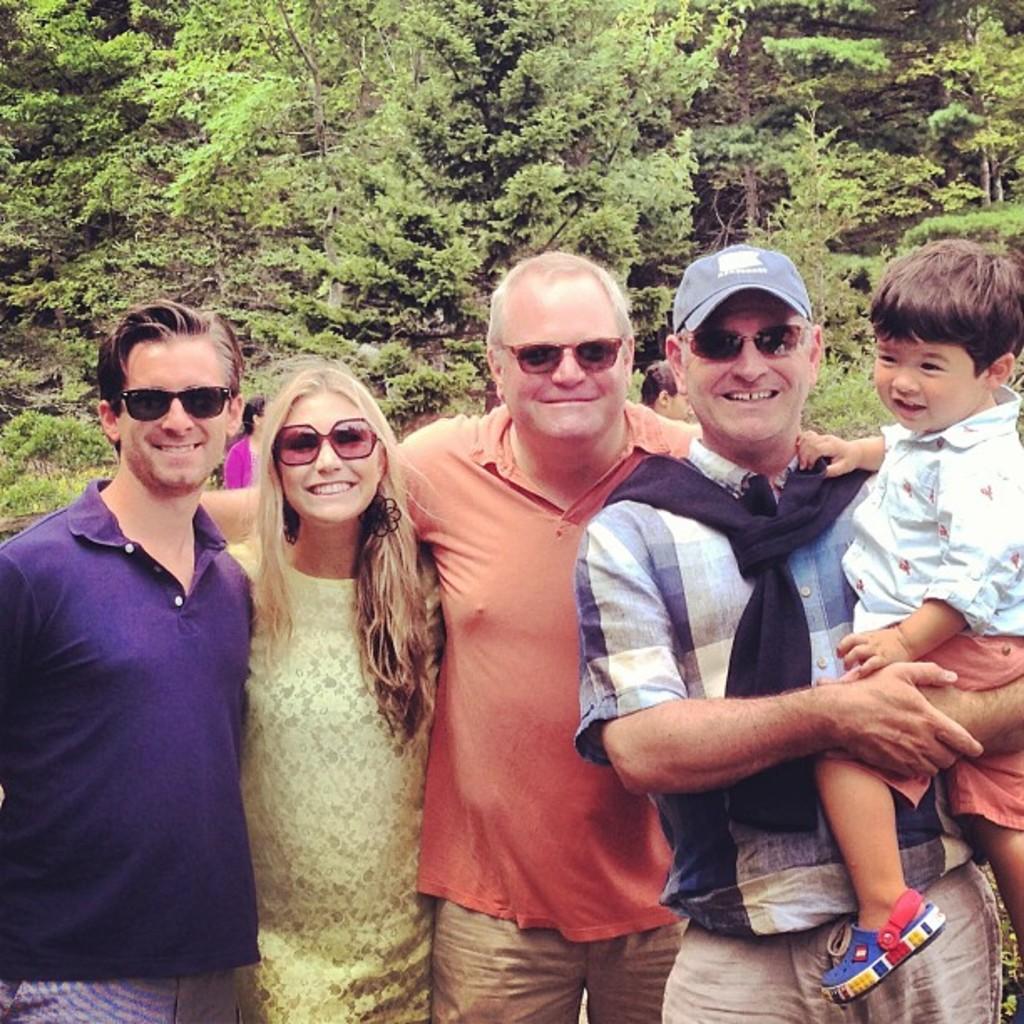How would you summarize this image in a sentence or two? A group of people are standing and smiling, behind them there are green color trees. 